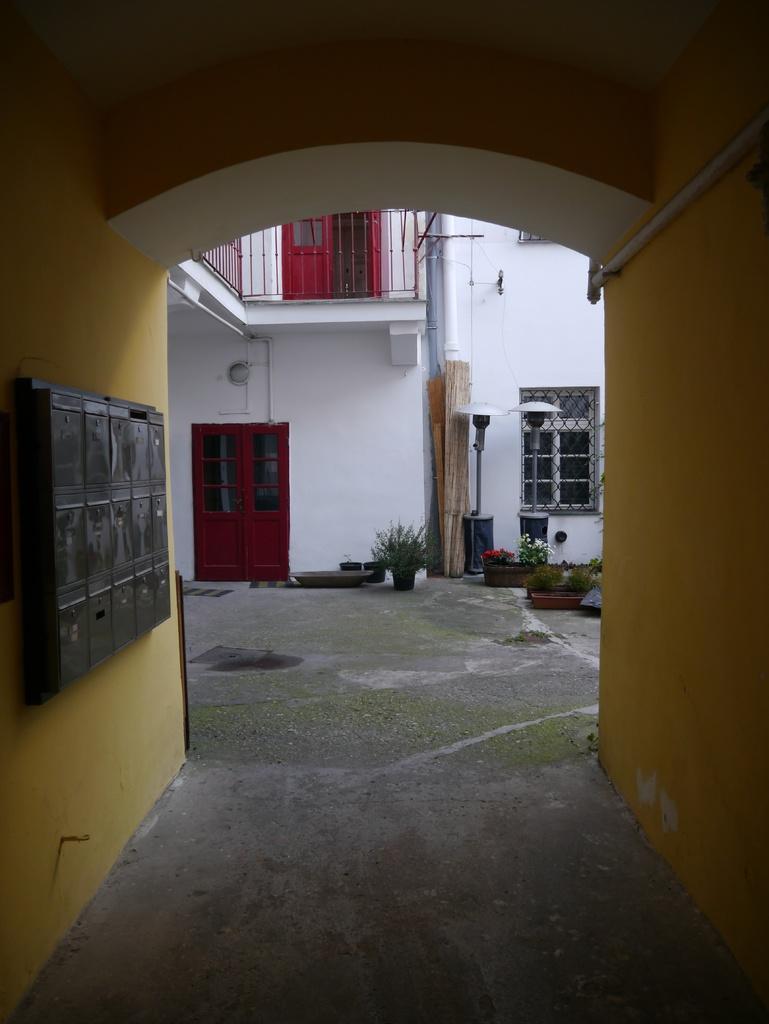Describe this image in one or two sentences. On the left side of the image there are post boxes on the wall. From the entrance we can see a door, a window, lamps and a few flower pots on the surface. Above the door there is another door with metal fence. There are pipes. 